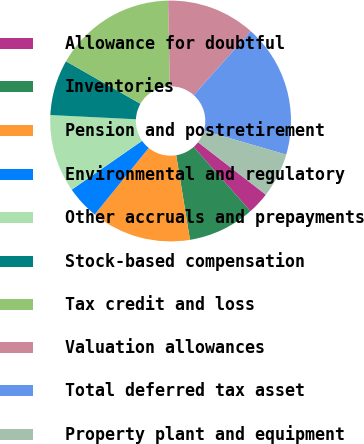Convert chart to OTSL. <chart><loc_0><loc_0><loc_500><loc_500><pie_chart><fcel>Allowance for doubtful<fcel>Inventories<fcel>Pension and postretirement<fcel>Environmental and regulatory<fcel>Other accruals and prepayments<fcel>Stock-based compensation<fcel>Tax credit and loss<fcel>Valuation allowances<fcel>Total deferred tax asset<fcel>Property plant and equipment<nl><fcel>2.99%<fcel>8.96%<fcel>13.43%<fcel>4.48%<fcel>10.45%<fcel>7.47%<fcel>16.41%<fcel>11.94%<fcel>17.9%<fcel>5.97%<nl></chart> 